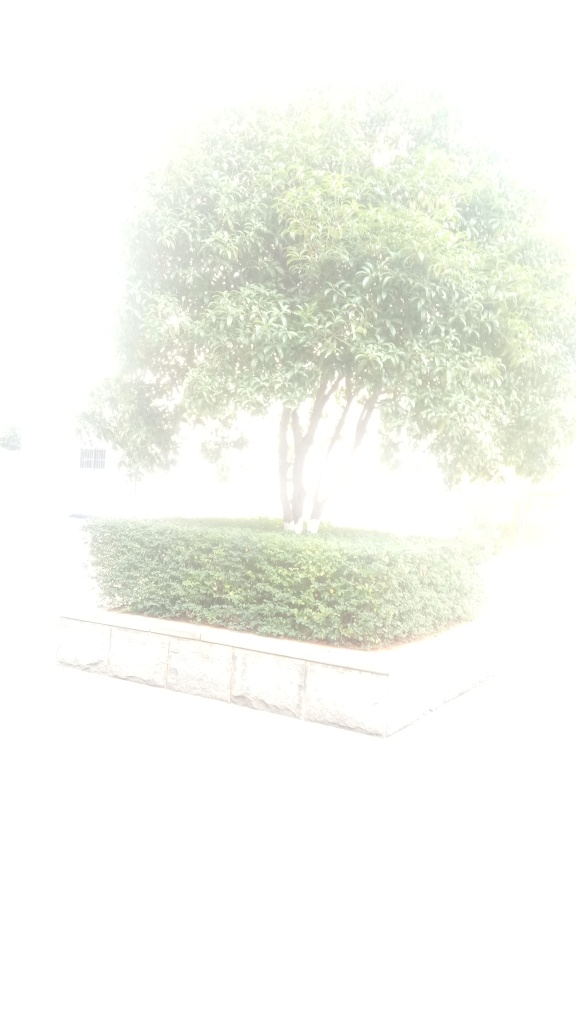Despite the overexposure, can you analyze what the subject of the photograph might be? It's difficult to discern many details in this overexposed photograph. However, the outline suggests there is a tree situated in the center, surrounded by some bushy vegetation maybe in a garden or park setting. The pale silhouette hints at a sunny day, perhaps midday when the sun is at its brightest, leading to the overexposure of the image. 